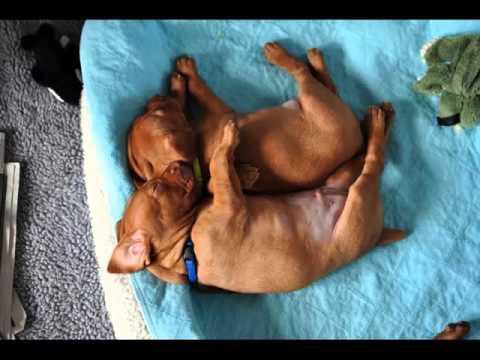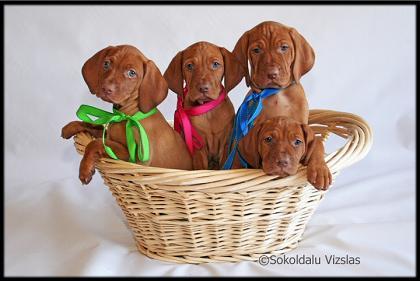The first image is the image on the left, the second image is the image on the right. Considering the images on both sides, is "The right image shows multiple dogs in a container, with at least one paw over the edge on each side." valid? Answer yes or no. Yes. The first image is the image on the left, the second image is the image on the right. Considering the images on both sides, is "There are 3 or more dogs in one of the images." valid? Answer yes or no. Yes. 